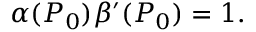<formula> <loc_0><loc_0><loc_500><loc_500>\alpha ( P _ { 0 } ) \beta ^ { \prime } ( P _ { 0 } ) = 1 .</formula> 